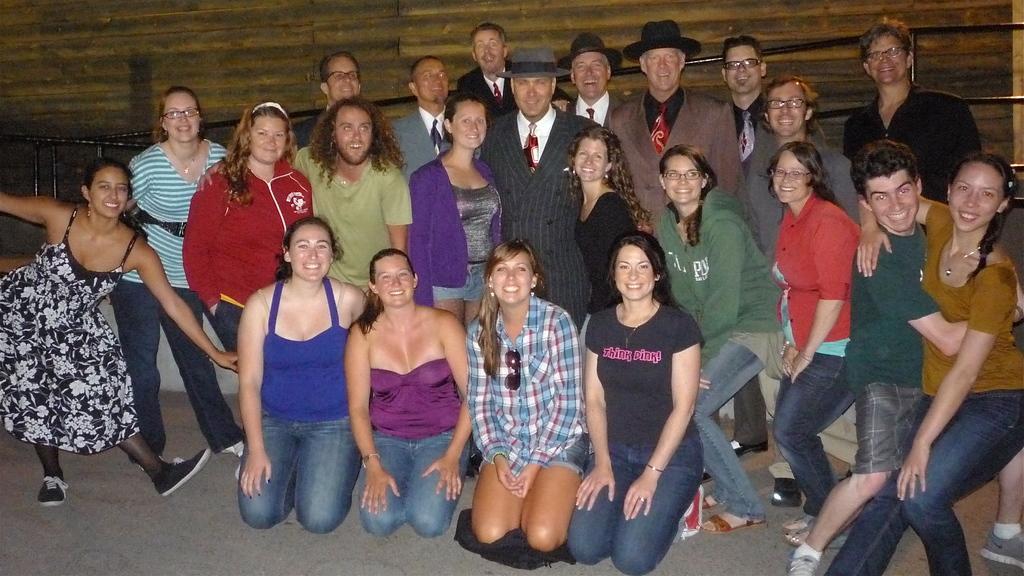Please provide a concise description of this image. In this picture we can see few persons are standing and in the front few persons are sitting on their knees. He is in suit and he wear a cap. This is the floor, and there is a wall on the background. 